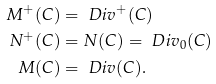Convert formula to latex. <formula><loc_0><loc_0><loc_500><loc_500>M ^ { + } ( C ) & = \ D i v ^ { + } ( C ) \\ N ^ { + } ( C ) & = N ( C ) = \ D i v _ { 0 } ( C ) \\ M ( C ) & = \ D i v ( C ) .</formula> 